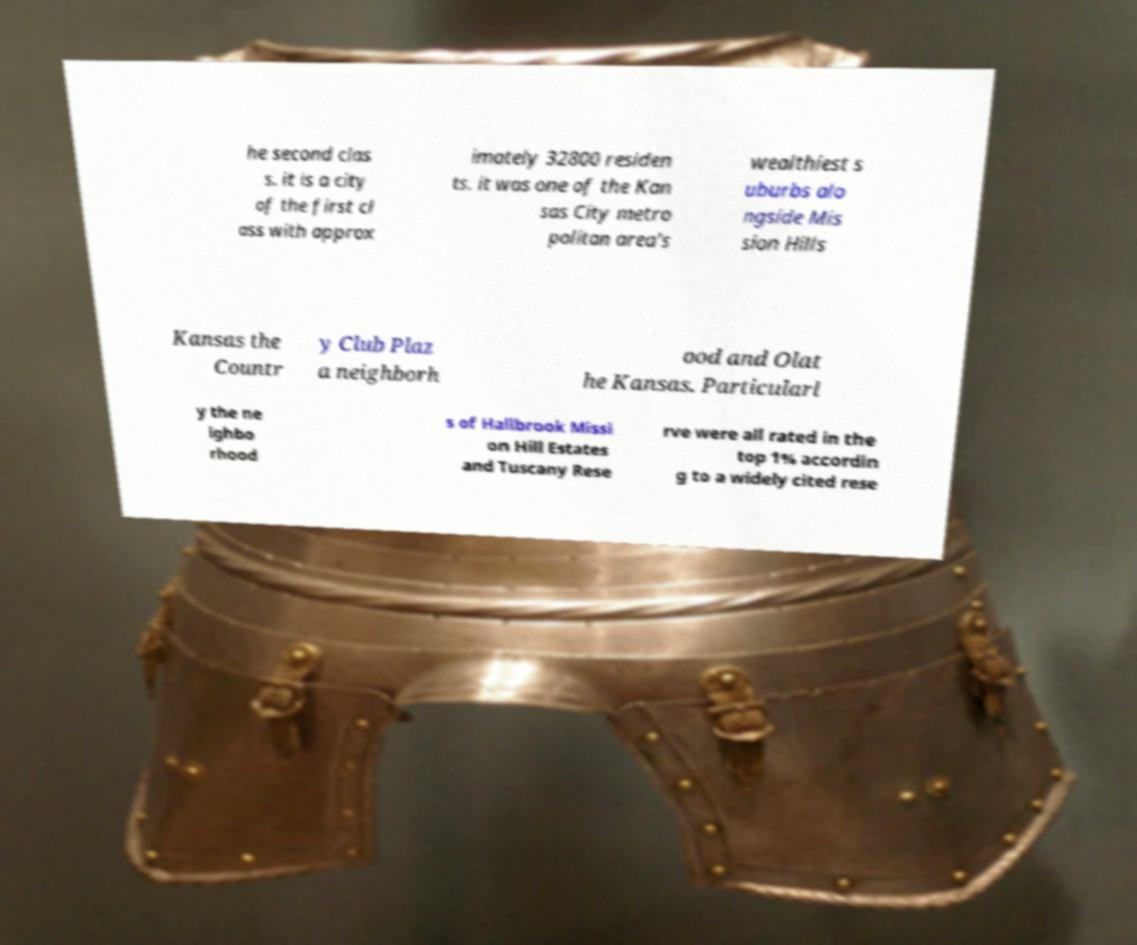Please identify and transcribe the text found in this image. he second clas s. it is a city of the first cl ass with approx imately 32800 residen ts. it was one of the Kan sas City metro politan area's wealthiest s uburbs alo ngside Mis sion Hills Kansas the Countr y Club Plaz a neighborh ood and Olat he Kansas. Particularl y the ne ighbo rhood s of Hallbrook Missi on Hill Estates and Tuscany Rese rve were all rated in the top 1% accordin g to a widely cited rese 